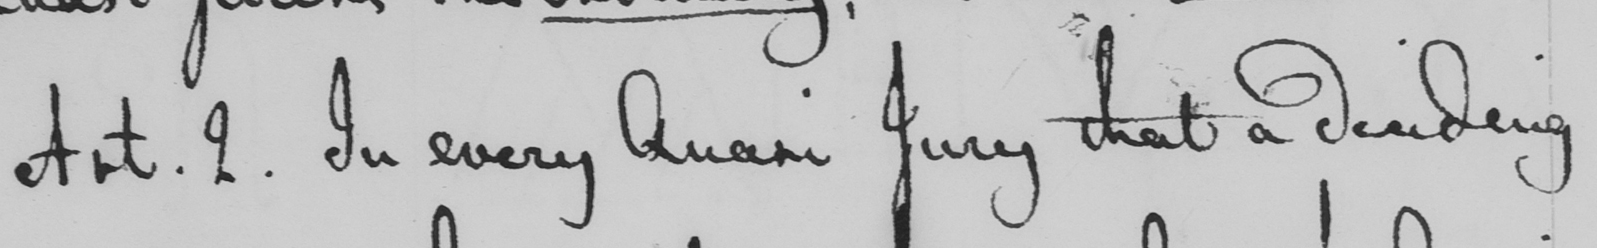What text is written in this handwritten line? Art . 2 . In every Quasi Jury that a deciding 